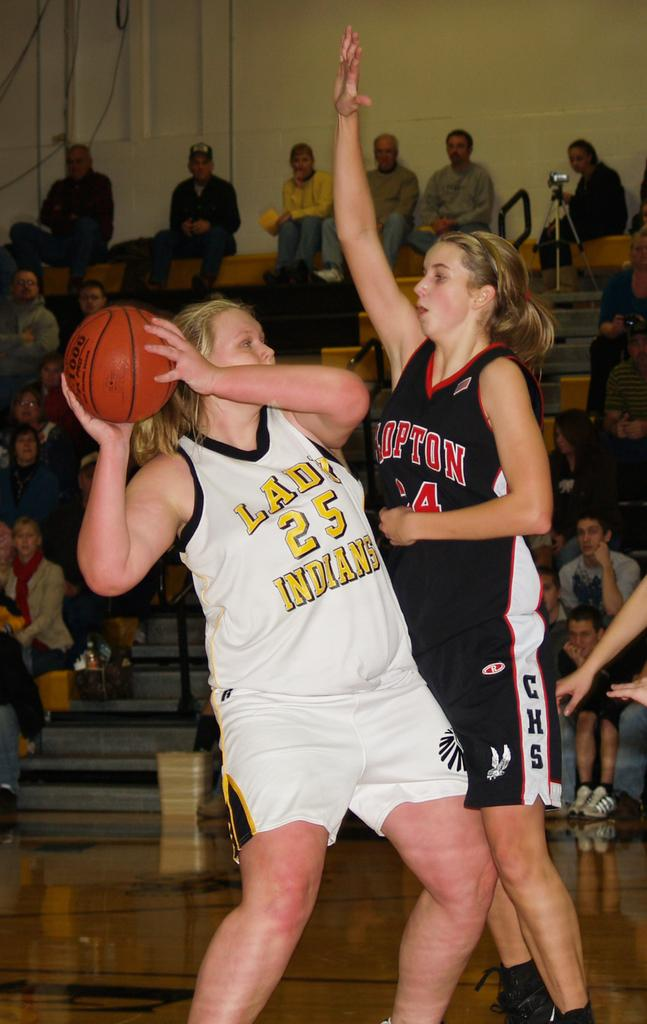<image>
Describe the image concisely. two female players playing basketball, The jerseys say Lady 25 Indians and Clopton 34. 